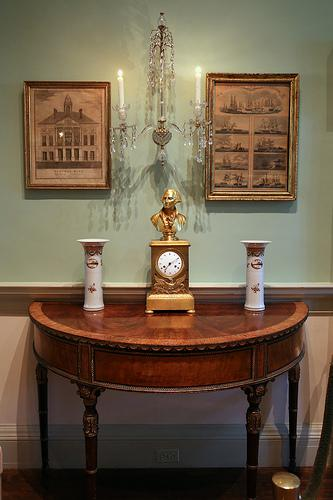Question: what is in the middle of the table?
Choices:
A. Center piece.
B. Flowers.
C. A clock.
D. Turkey.
Answer with the letter. Answer: C Question: how many legs does the table have?
Choices:
A. Five.
B. Six.
C. Four.
D. Two.
Answer with the letter. Answer: C Question: what is the light fixture made of?
Choices:
A. Crystals.
B. Glass.
C. Metal.
D. Marble.
Answer with the letter. Answer: A Question: what is the left picture of?
Choices:
A. A building.
B. Restaurant.
C. Shop.
D. A house.
Answer with the letter. Answer: D Question: where are the matching vases?
Choices:
A. Flanking the clock.
B. On the shelf.
C. End tables.
D. On the Mantel.
Answer with the letter. Answer: A Question: how many lights are on the fixture?
Choices:
A. Three.
B. Four.
C. Two.
D. Five.
Answer with the letter. Answer: C 